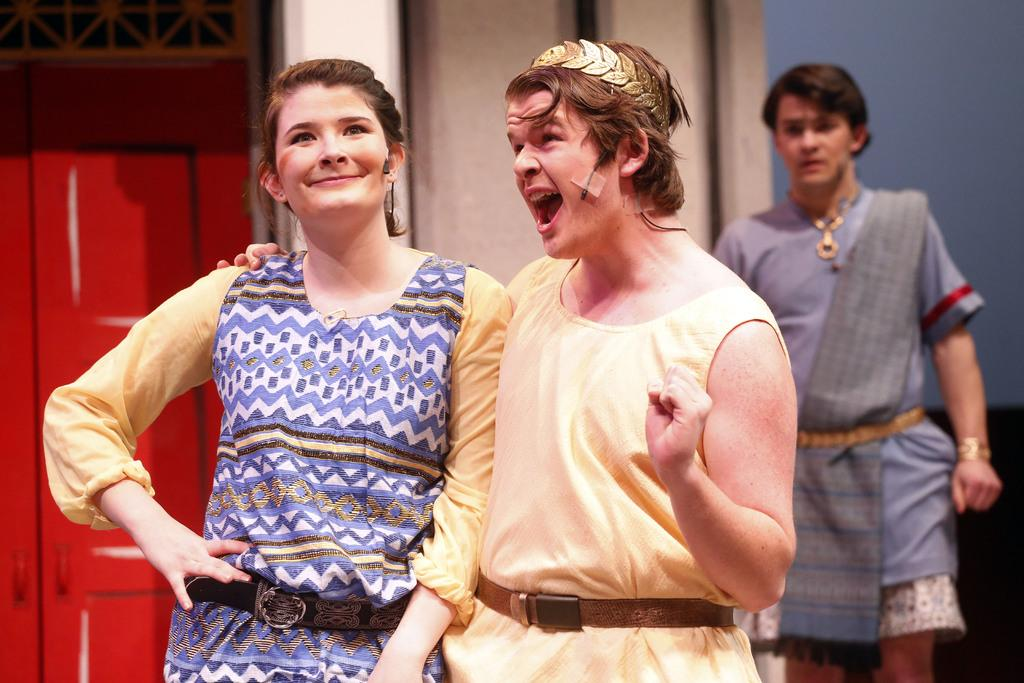How many people are present in the image? There are three people in the image. What objects are visible in the image that might be used for amplifying sound? There are microphones in the image. Can you describe the expression of one of the people in the image? A woman is smiling in the image. What type of architectural feature can be seen in the background of the image? There are doors visible in the background of the image. What is the general setting of the image? There is a wall in the background of the image, which suggests an indoor setting. What type of stew is being prepared in the yard in the image? There is no stew or yard present in the image; it features three people and microphones in an indoor setting. 